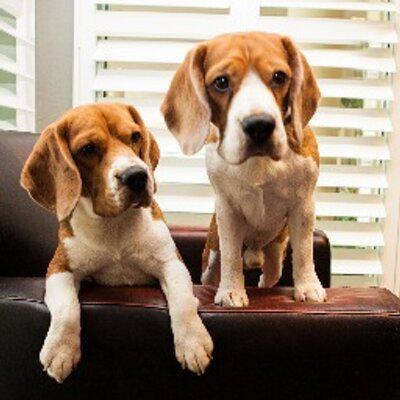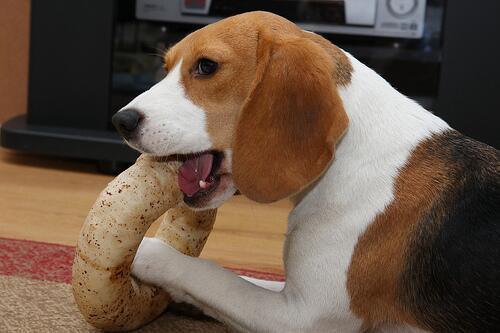The first image is the image on the left, the second image is the image on the right. For the images shown, is this caption "An image shows a person's hand around at least one beagle dog." true? Answer yes or no. No. 